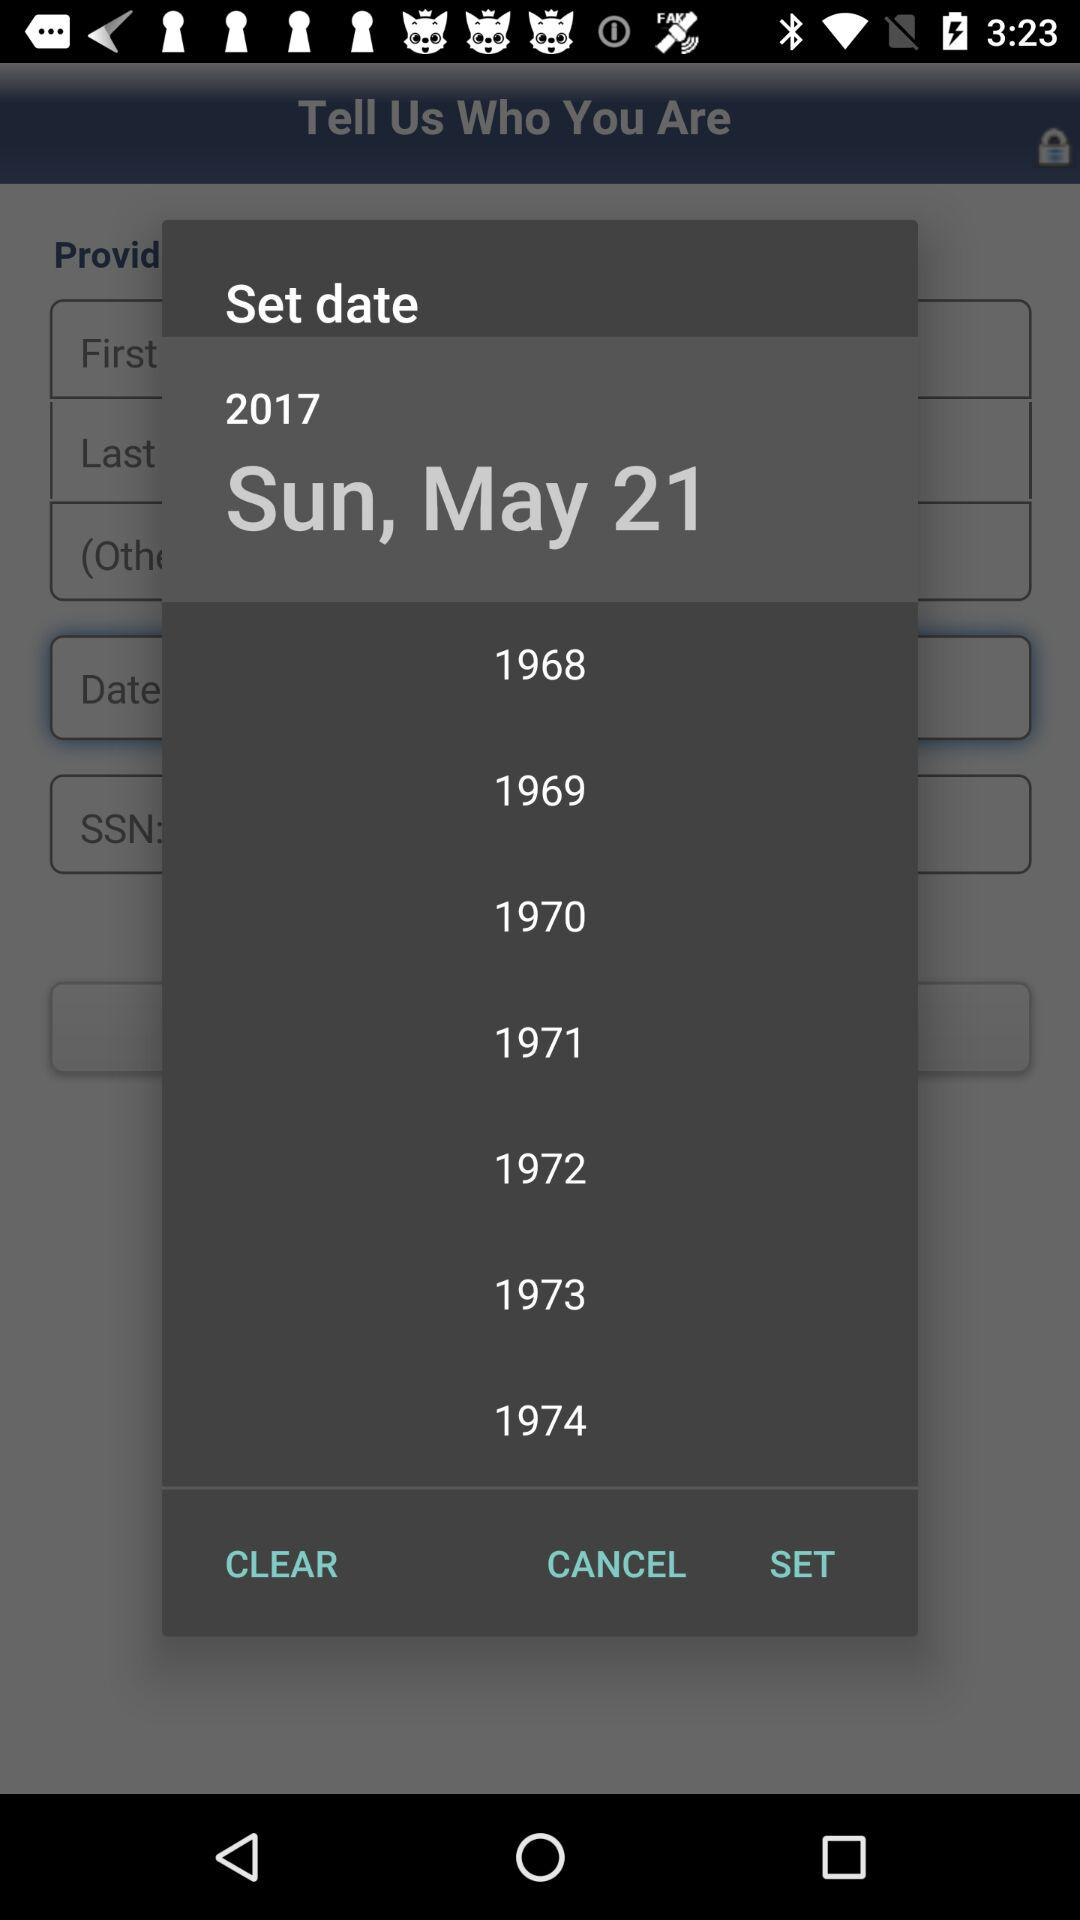What is the set date? The set date is Sunday, May 21, 2017. 